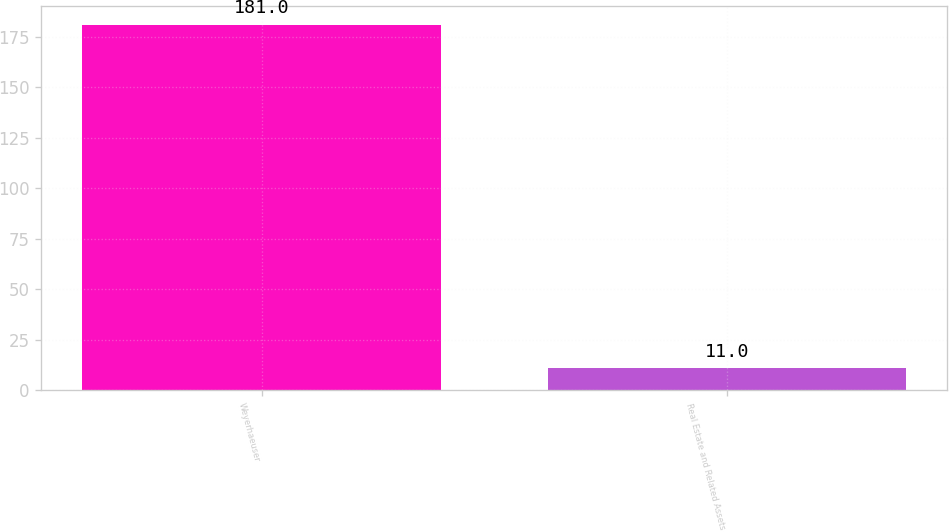Convert chart. <chart><loc_0><loc_0><loc_500><loc_500><bar_chart><fcel>Weyerhaeuser<fcel>Real Estate and Related Assets<nl><fcel>181<fcel>11<nl></chart> 